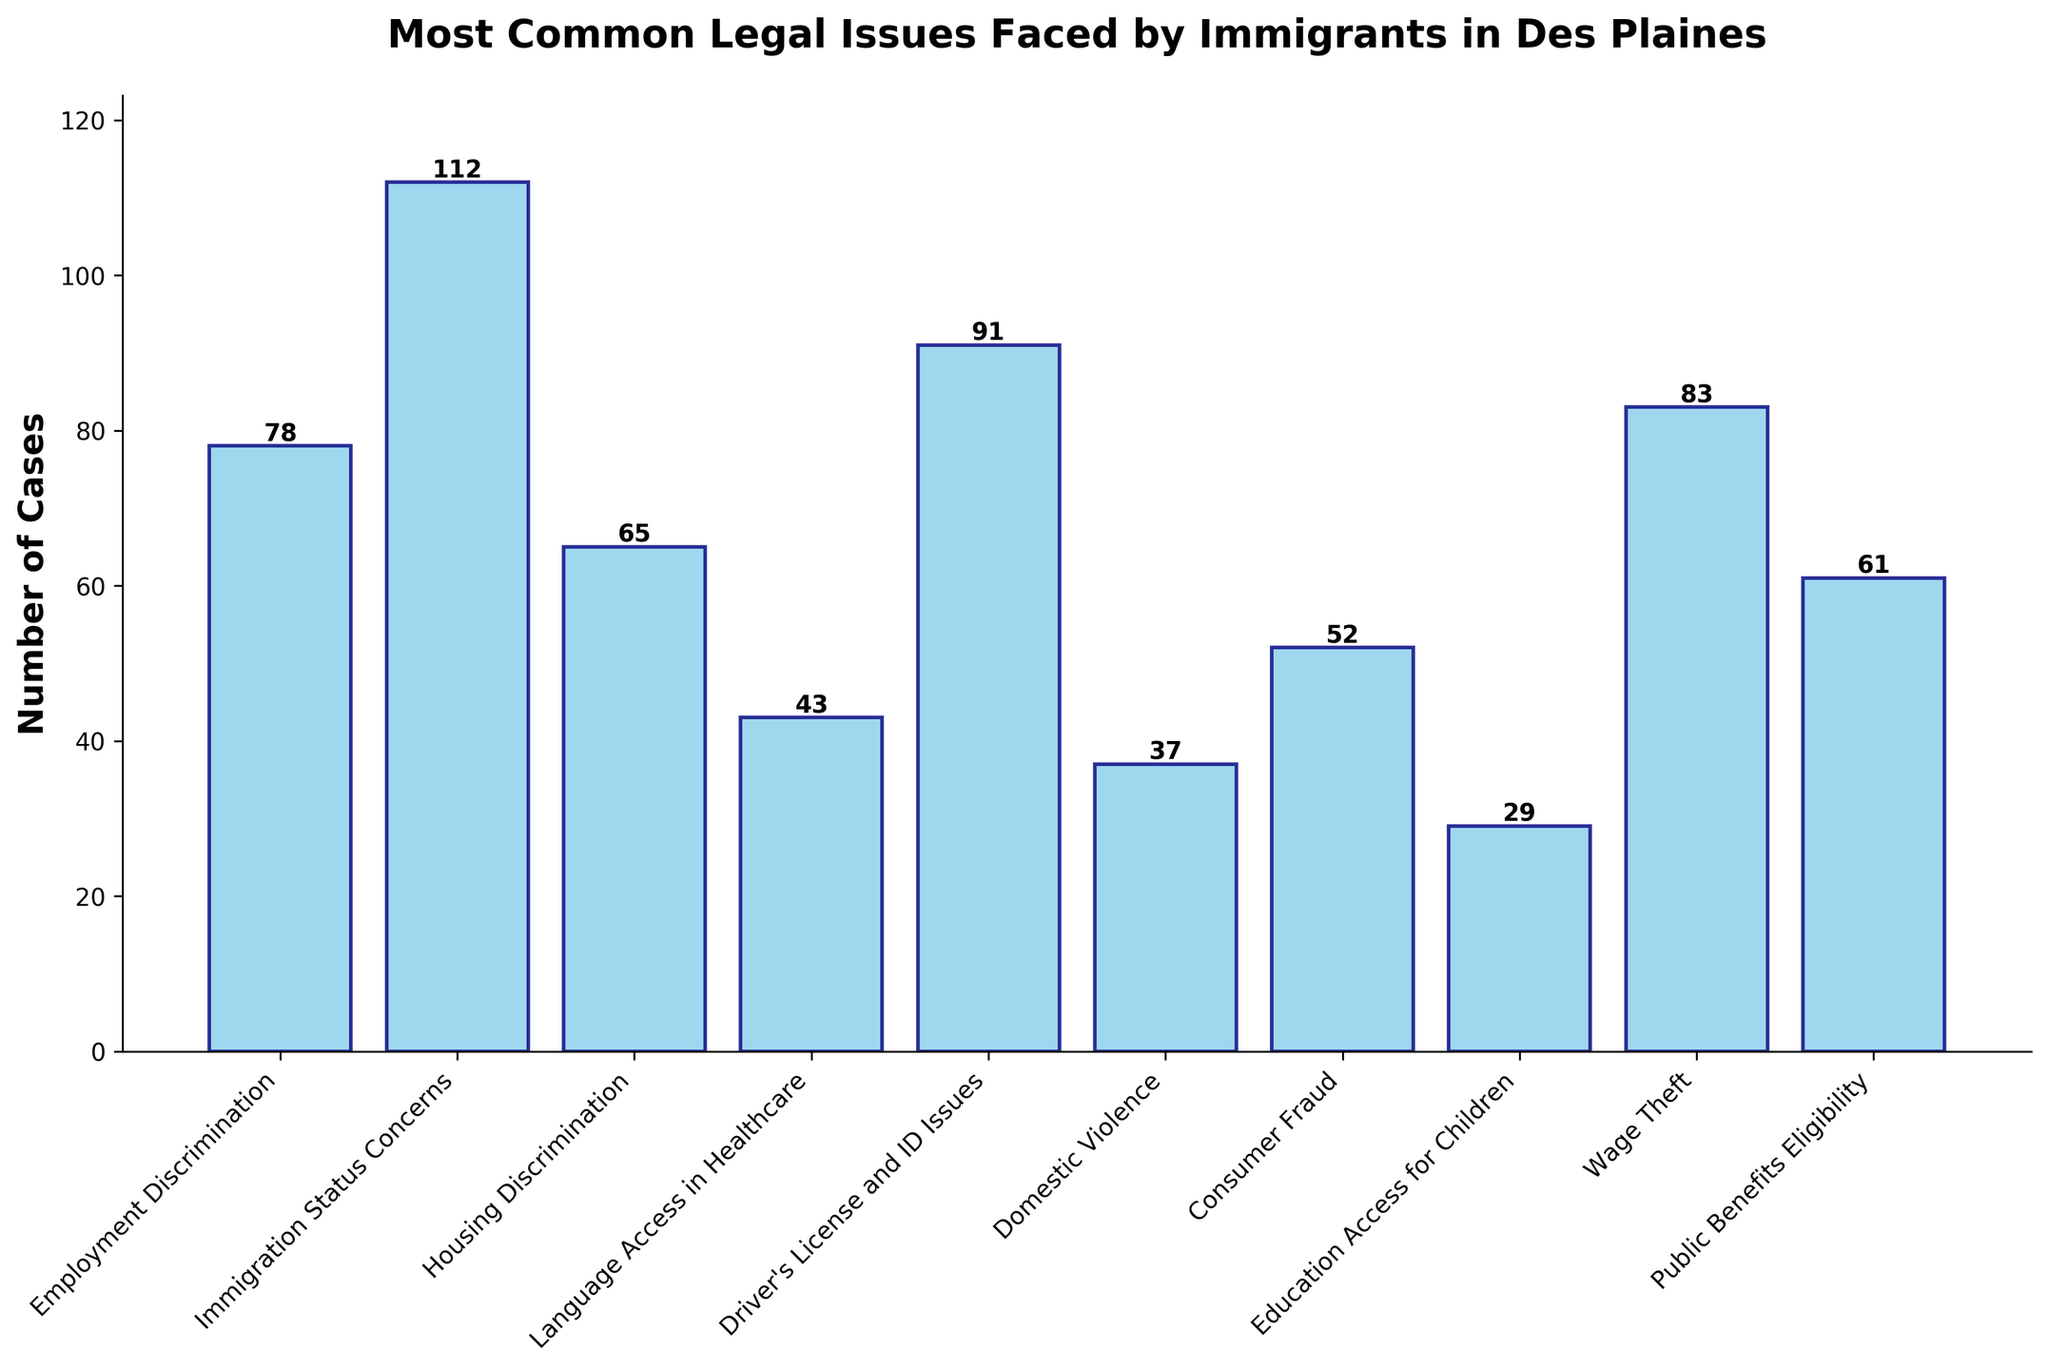What is the most common legal issue faced by immigrants in Des Plaines? By looking at the heights of the bars, the tallest bar indicates the most common legal issue. The tallest bar corresponds to "Immigration Status Concerns."
Answer: Immigration Status Concerns Which legal issue has the least number of cases? By identifying the shortest bar, the legal issue with the least number of cases is shown as "Education Access for Children," which has the shortest height.
Answer: Education Access for Children How many more cases of Driver's License and ID Issues are there compared to Housing Discrimination? The number of cases for Driver's License and ID Issues is 91, and for Housing Discrimination, it is 65. The difference is calculated as 91 - 65.
Answer: 26 What is the combined number of cases for Employment Discrimination and Wage Theft? The number of cases for Employment Discrimination is 78, and for Wage Theft, it is 83. Adding these together gives 78 + 83.
Answer: 161 Is the number of Domestic Violence cases greater or less than the number of Consumer Fraud cases? The number of cases for Domestic Violence is 37, and for Consumer Fraud, it is 52. Since 37 is less than 52, Domestic Violence cases are fewer.
Answer: Less than How many total cases are there for all the listed legal issues? The total number of cases is found by summing up the cases for all issues: 78 + 112 + 65 + 43 + 91 + 37 + 52 + 29 + 83 + 61.
Answer: 651 Which two legal issues have nearly the same number of cases? By comparing the heights of the bars closely, "Employment Discrimination" with 78 cases and "Wage Theft" with 83 cases have numbers very close to each other.
Answer: Employment Discrimination and Wage Theft What is the difference between the number of cases for Language Access in Healthcare and Public Benefits Eligibility? The number of cases for Language Access in Healthcare is 43, and for Public Benefits Eligibility, it is 61. The difference can be calculated as 61 - 43.
Answer: 18 What visual color is used for the bars in the chart? The bars in the chart are described visually as having a sky-blue color with navy edges.
Answer: Sky-blue with navy edges Which legal issue ranks third in terms of the number of cases? By sorting and comparing the heights of the bars, the third-highest bar corresponds to "Driver's License and ID Issues" with 91 cases.
Answer: Driver's License and ID Issues 